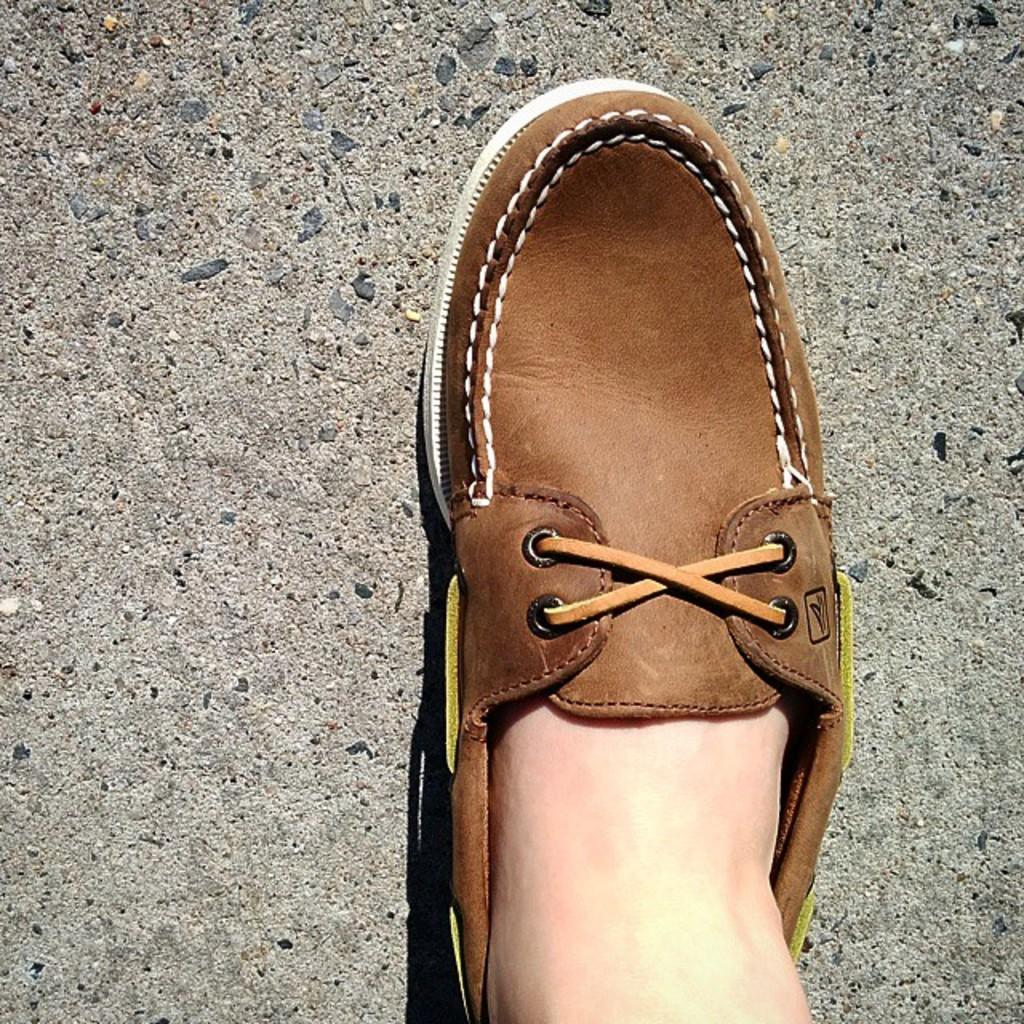What part of a person's body is visible in the image? There is a person's leg in the image. What is covering the person's foot in the image? The person's leg has a shoe on it. Where is the leg and shoe located in the image? The leg and shoe are on the ground. What type of coat is being worn by the person in the image? There is no coat visible in the image; only a leg and shoe are present. 